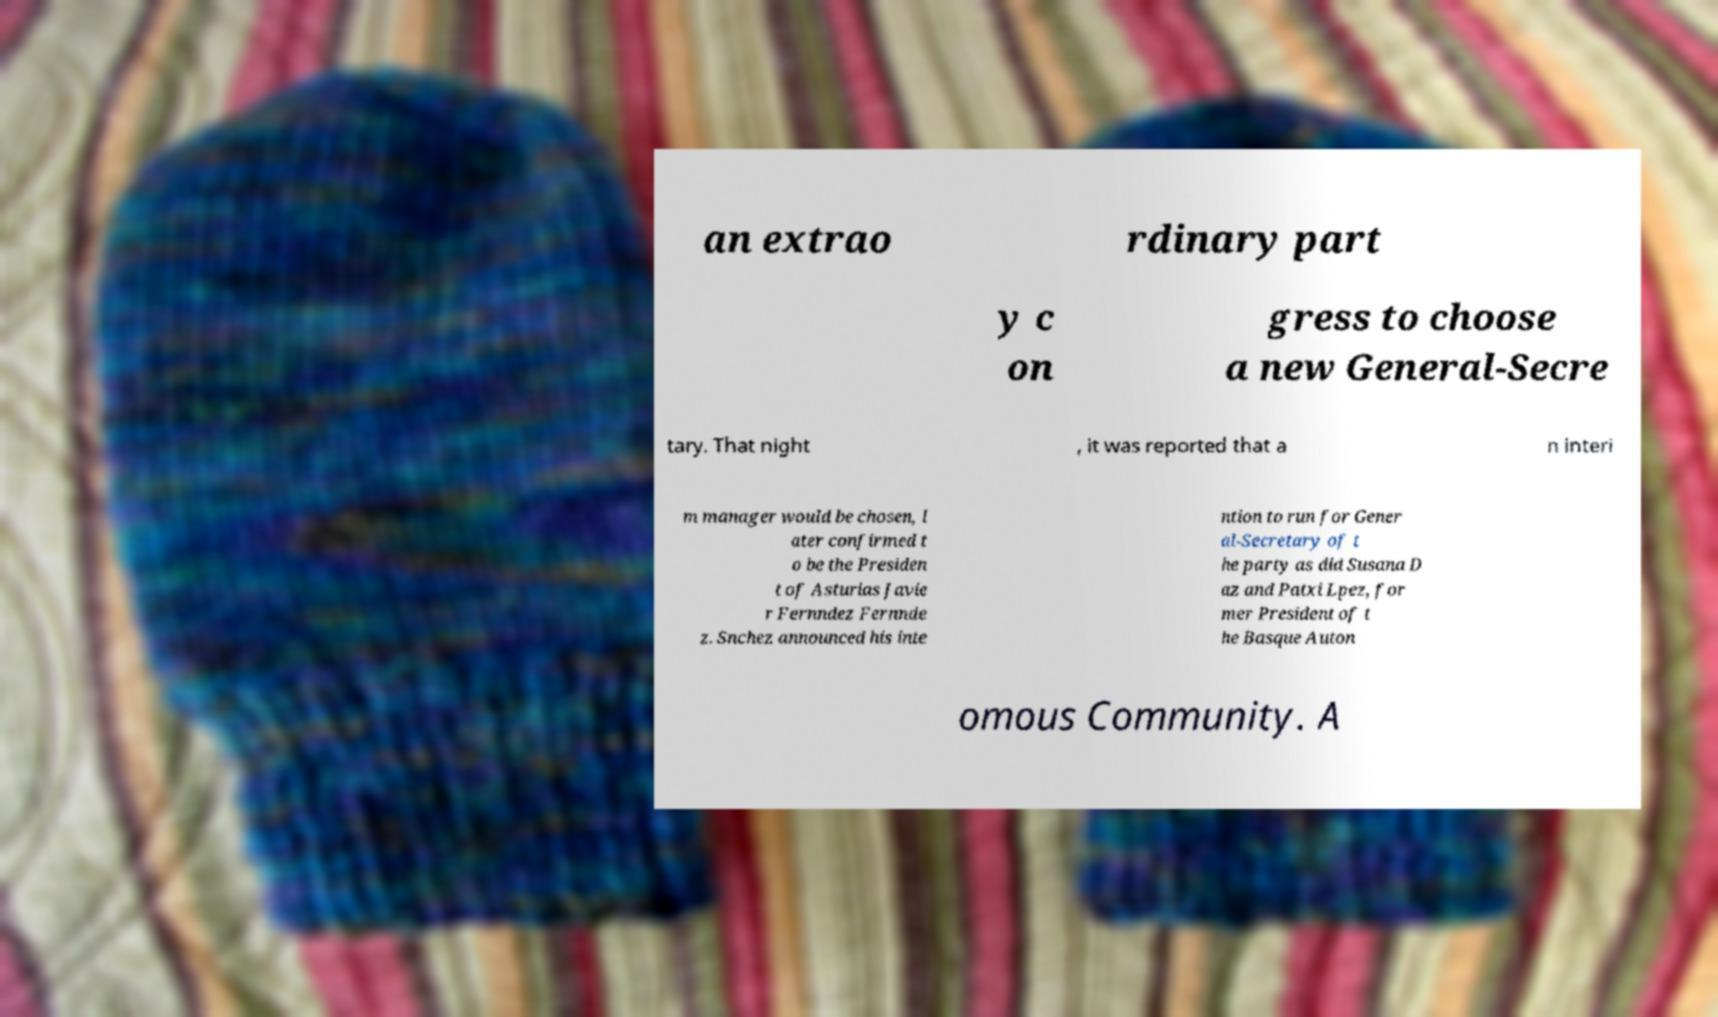For documentation purposes, I need the text within this image transcribed. Could you provide that? an extrao rdinary part y c on gress to choose a new General-Secre tary. That night , it was reported that a n interi m manager would be chosen, l ater confirmed t o be the Presiden t of Asturias Javie r Fernndez Fernnde z. Snchez announced his inte ntion to run for Gener al-Secretary of t he party as did Susana D az and Patxi Lpez, for mer President of t he Basque Auton omous Community. A 